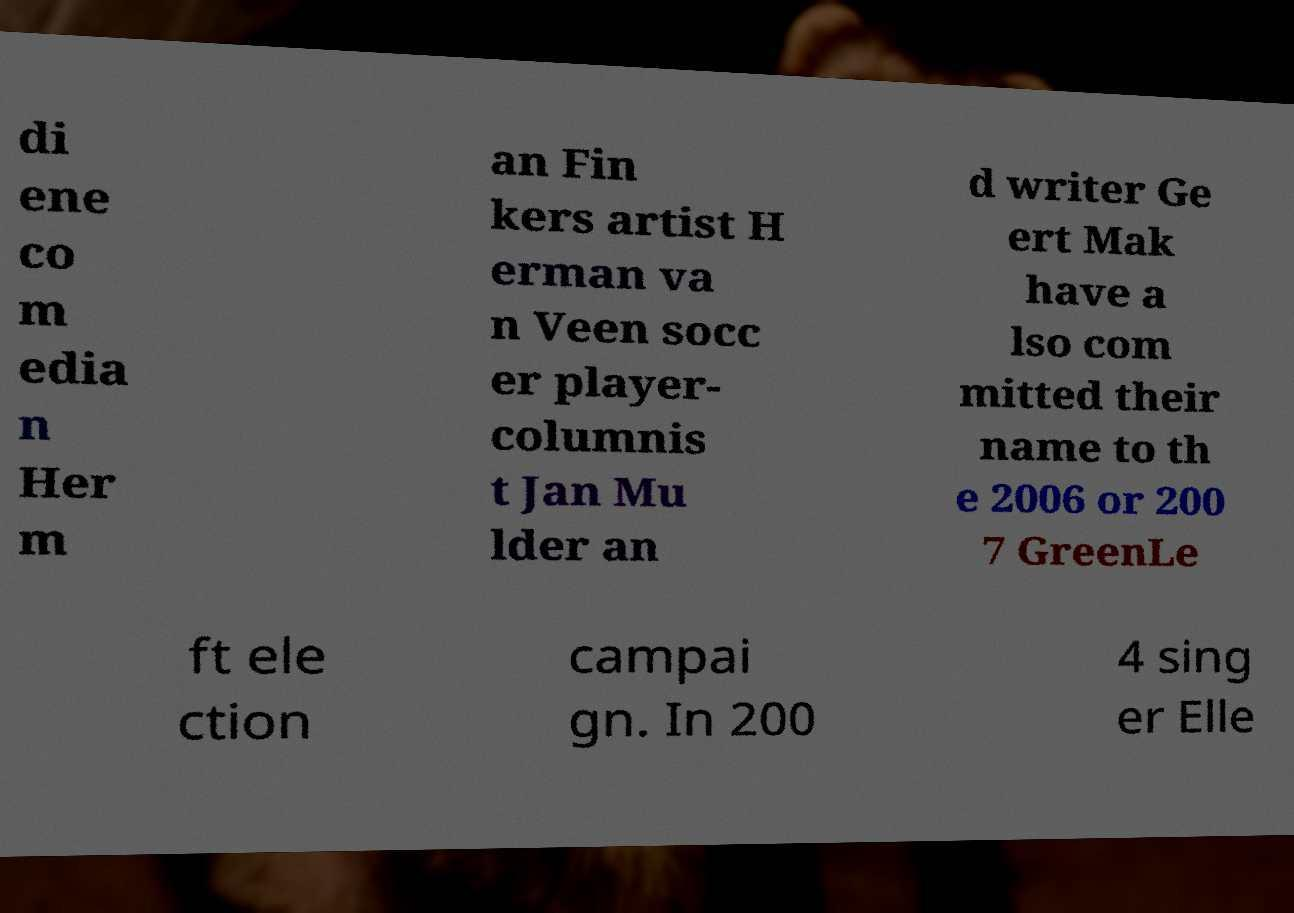There's text embedded in this image that I need extracted. Can you transcribe it verbatim? di ene co m edia n Her m an Fin kers artist H erman va n Veen socc er player- columnis t Jan Mu lder an d writer Ge ert Mak have a lso com mitted their name to th e 2006 or 200 7 GreenLe ft ele ction campai gn. In 200 4 sing er Elle 